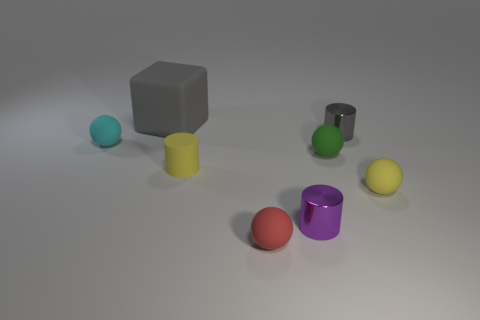Is the number of small red matte things greater than the number of red metallic cylinders?
Provide a short and direct response. Yes. What number of other things are the same shape as the small cyan matte thing?
Provide a short and direct response. 3. The small sphere that is behind the yellow matte cylinder and on the right side of the small purple metal cylinder is made of what material?
Give a very brief answer. Rubber. How big is the matte block?
Give a very brief answer. Large. There is a tiny yellow thing on the left side of the gray object to the right of the big thing; how many things are right of it?
Offer a very short reply. 5. There is a matte thing that is behind the gray thing in front of the matte cube; what shape is it?
Provide a short and direct response. Cube. Is there anything else that has the same size as the block?
Your answer should be compact. No. There is a cylinder in front of the yellow cylinder; what is its color?
Keep it short and to the point. Purple. What is the gray thing that is to the right of the thing in front of the cylinder in front of the rubber cylinder made of?
Your answer should be very brief. Metal. What is the size of the metallic thing behind the ball on the left side of the big object?
Offer a very short reply. Small. 